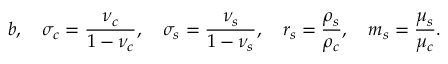<formula> <loc_0><loc_0><loc_500><loc_500>b , \quad \sigma _ { c } = \frac { \nu _ { c } } { 1 - \nu _ { c } } , \quad \sigma _ { s } = \frac { \nu _ { s } } { 1 - \nu _ { s } } , \quad r _ { s } = \frac { \rho _ { s } } { \rho _ { c } } , \quad m _ { s } = \frac { \mu _ { s } } { \mu _ { c } } .</formula> 